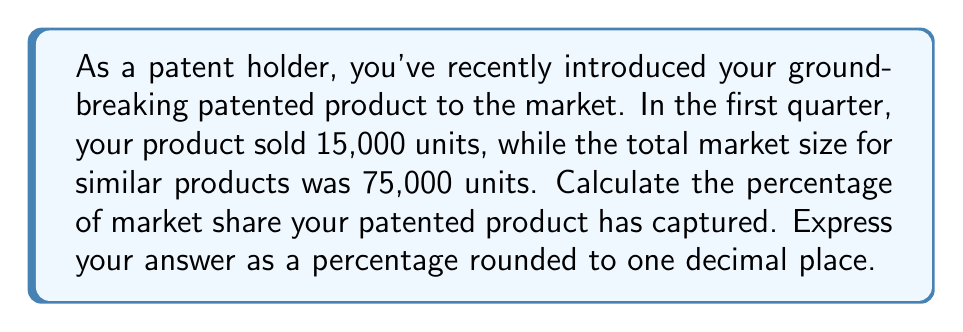Can you solve this math problem? To calculate the percentage of market share, we need to use the following formula:

$$ \text{Market Share} = \frac{\text{Units Sold by Your Product}}{\text{Total Market Size}} \times 100\% $$

Let's plug in the given values:

$$ \text{Market Share} = \frac{15,000}{75,000} \times 100\% $$

Now, let's solve this step-by-step:

1) First, divide 15,000 by 75,000:
   $$ \frac{15,000}{75,000} = 0.2 $$

2) Multiply this result by 100 to convert to a percentage:
   $$ 0.2 \times 100 = 20\% $$

3) The question asks for the answer rounded to one decimal place. 20% already has zero decimal places, so no further rounding is necessary.

Therefore, your patented product has captured 20.0% of the market share.
Answer: 20.0% 